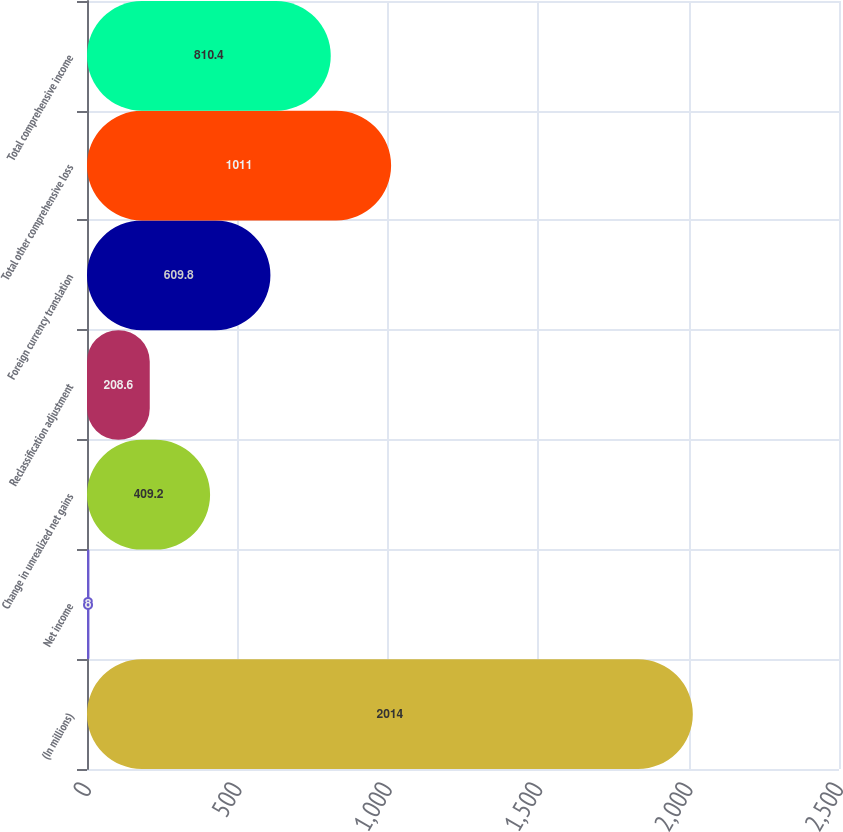Convert chart. <chart><loc_0><loc_0><loc_500><loc_500><bar_chart><fcel>(In millions)<fcel>Net income<fcel>Change in unrealized net gains<fcel>Reclassification adjustment<fcel>Foreign currency translation<fcel>Total other comprehensive loss<fcel>Total comprehensive income<nl><fcel>2014<fcel>8<fcel>409.2<fcel>208.6<fcel>609.8<fcel>1011<fcel>810.4<nl></chart> 